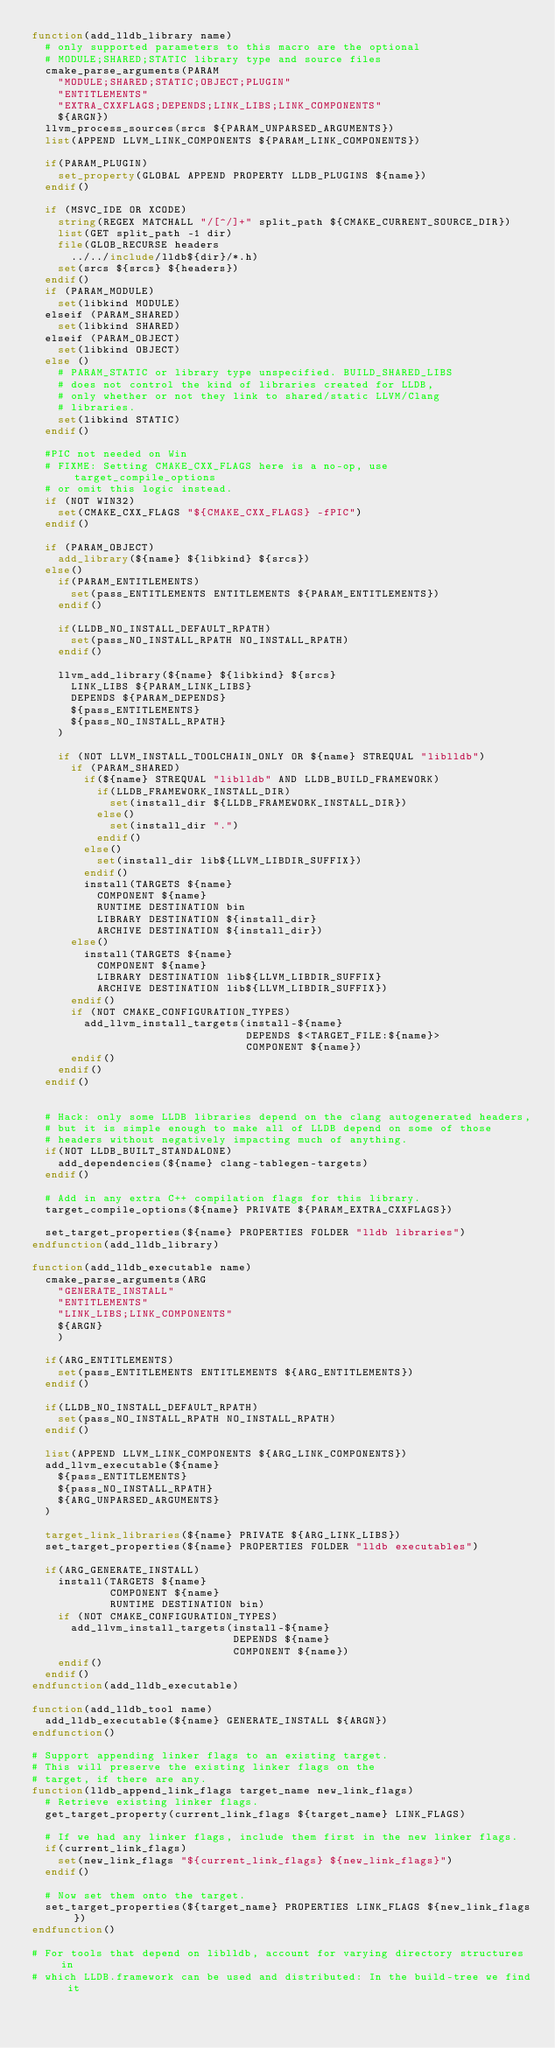<code> <loc_0><loc_0><loc_500><loc_500><_CMake_>function(add_lldb_library name)
  # only supported parameters to this macro are the optional
  # MODULE;SHARED;STATIC library type and source files
  cmake_parse_arguments(PARAM
    "MODULE;SHARED;STATIC;OBJECT;PLUGIN"
    "ENTITLEMENTS"
    "EXTRA_CXXFLAGS;DEPENDS;LINK_LIBS;LINK_COMPONENTS"
    ${ARGN})
  llvm_process_sources(srcs ${PARAM_UNPARSED_ARGUMENTS})
  list(APPEND LLVM_LINK_COMPONENTS ${PARAM_LINK_COMPONENTS})

  if(PARAM_PLUGIN)
    set_property(GLOBAL APPEND PROPERTY LLDB_PLUGINS ${name})
  endif()

  if (MSVC_IDE OR XCODE)
    string(REGEX MATCHALL "/[^/]+" split_path ${CMAKE_CURRENT_SOURCE_DIR})
    list(GET split_path -1 dir)
    file(GLOB_RECURSE headers
      ../../include/lldb${dir}/*.h)
    set(srcs ${srcs} ${headers})
  endif()
  if (PARAM_MODULE)
    set(libkind MODULE)
  elseif (PARAM_SHARED)
    set(libkind SHARED)
  elseif (PARAM_OBJECT)
    set(libkind OBJECT)
  else ()
    # PARAM_STATIC or library type unspecified. BUILD_SHARED_LIBS
    # does not control the kind of libraries created for LLDB,
    # only whether or not they link to shared/static LLVM/Clang
    # libraries.
    set(libkind STATIC)
  endif()

  #PIC not needed on Win
  # FIXME: Setting CMAKE_CXX_FLAGS here is a no-op, use target_compile_options
  # or omit this logic instead.
  if (NOT WIN32)
    set(CMAKE_CXX_FLAGS "${CMAKE_CXX_FLAGS} -fPIC")
  endif()

  if (PARAM_OBJECT)
    add_library(${name} ${libkind} ${srcs})
  else()
    if(PARAM_ENTITLEMENTS)
      set(pass_ENTITLEMENTS ENTITLEMENTS ${PARAM_ENTITLEMENTS})
    endif()

    if(LLDB_NO_INSTALL_DEFAULT_RPATH)
      set(pass_NO_INSTALL_RPATH NO_INSTALL_RPATH)
    endif()

    llvm_add_library(${name} ${libkind} ${srcs}
      LINK_LIBS ${PARAM_LINK_LIBS}
      DEPENDS ${PARAM_DEPENDS}
      ${pass_ENTITLEMENTS}
      ${pass_NO_INSTALL_RPATH}
    )

    if (NOT LLVM_INSTALL_TOOLCHAIN_ONLY OR ${name} STREQUAL "liblldb")
      if (PARAM_SHARED)
        if(${name} STREQUAL "liblldb" AND LLDB_BUILD_FRAMEWORK)
          if(LLDB_FRAMEWORK_INSTALL_DIR)
            set(install_dir ${LLDB_FRAMEWORK_INSTALL_DIR})
          else()
            set(install_dir ".")
          endif()
        else()
          set(install_dir lib${LLVM_LIBDIR_SUFFIX})
        endif()
        install(TARGETS ${name}
          COMPONENT ${name}
          RUNTIME DESTINATION bin
          LIBRARY DESTINATION ${install_dir}
          ARCHIVE DESTINATION ${install_dir})
      else()
        install(TARGETS ${name}
          COMPONENT ${name}
          LIBRARY DESTINATION lib${LLVM_LIBDIR_SUFFIX}
          ARCHIVE DESTINATION lib${LLVM_LIBDIR_SUFFIX})
      endif()
      if (NOT CMAKE_CONFIGURATION_TYPES)
        add_llvm_install_targets(install-${name}
                                 DEPENDS $<TARGET_FILE:${name}>
                                 COMPONENT ${name})
      endif()
    endif()
  endif()


  # Hack: only some LLDB libraries depend on the clang autogenerated headers,
  # but it is simple enough to make all of LLDB depend on some of those
  # headers without negatively impacting much of anything.
  if(NOT LLDB_BUILT_STANDALONE)
    add_dependencies(${name} clang-tablegen-targets)
  endif()

  # Add in any extra C++ compilation flags for this library.
  target_compile_options(${name} PRIVATE ${PARAM_EXTRA_CXXFLAGS})

  set_target_properties(${name} PROPERTIES FOLDER "lldb libraries")
endfunction(add_lldb_library)

function(add_lldb_executable name)
  cmake_parse_arguments(ARG
    "GENERATE_INSTALL"
    "ENTITLEMENTS"
    "LINK_LIBS;LINK_COMPONENTS"
    ${ARGN}
    )

  if(ARG_ENTITLEMENTS)
    set(pass_ENTITLEMENTS ENTITLEMENTS ${ARG_ENTITLEMENTS})
  endif()

  if(LLDB_NO_INSTALL_DEFAULT_RPATH)
    set(pass_NO_INSTALL_RPATH NO_INSTALL_RPATH)
  endif()

  list(APPEND LLVM_LINK_COMPONENTS ${ARG_LINK_COMPONENTS})
  add_llvm_executable(${name}
    ${pass_ENTITLEMENTS}
    ${pass_NO_INSTALL_RPATH}
    ${ARG_UNPARSED_ARGUMENTS}
  )

  target_link_libraries(${name} PRIVATE ${ARG_LINK_LIBS})
  set_target_properties(${name} PROPERTIES FOLDER "lldb executables")

  if(ARG_GENERATE_INSTALL)
    install(TARGETS ${name}
            COMPONENT ${name}
            RUNTIME DESTINATION bin)
    if (NOT CMAKE_CONFIGURATION_TYPES)
      add_llvm_install_targets(install-${name}
                               DEPENDS ${name}
                               COMPONENT ${name})
    endif()
  endif()
endfunction(add_lldb_executable)

function(add_lldb_tool name)
  add_lldb_executable(${name} GENERATE_INSTALL ${ARGN})
endfunction()

# Support appending linker flags to an existing target.
# This will preserve the existing linker flags on the
# target, if there are any.
function(lldb_append_link_flags target_name new_link_flags)
  # Retrieve existing linker flags.
  get_target_property(current_link_flags ${target_name} LINK_FLAGS)

  # If we had any linker flags, include them first in the new linker flags.
  if(current_link_flags)
    set(new_link_flags "${current_link_flags} ${new_link_flags}")
  endif()

  # Now set them onto the target.
  set_target_properties(${target_name} PROPERTIES LINK_FLAGS ${new_link_flags})
endfunction()

# For tools that depend on liblldb, account for varying directory structures in
# which LLDB.framework can be used and distributed: In the build-tree we find it</code> 